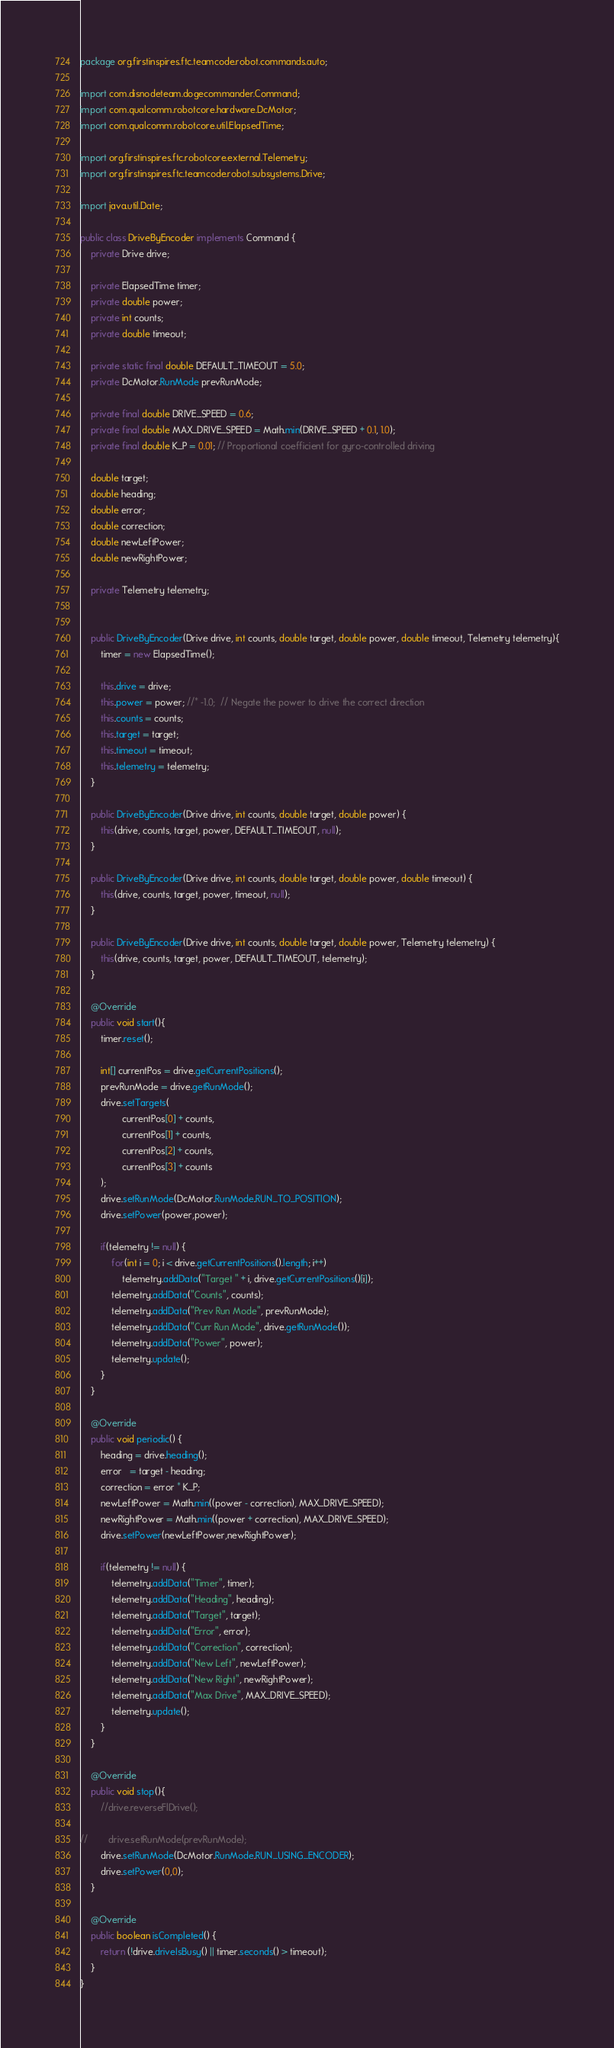Convert code to text. <code><loc_0><loc_0><loc_500><loc_500><_Java_>package org.firstinspires.ftc.teamcode.robot.commands.auto;

import com.disnodeteam.dogecommander.Command;
import com.qualcomm.robotcore.hardware.DcMotor;
import com.qualcomm.robotcore.util.ElapsedTime;

import org.firstinspires.ftc.robotcore.external.Telemetry;
import org.firstinspires.ftc.teamcode.robot.subsystems.Drive;

import java.util.Date;

public class DriveByEncoder implements Command {
    private Drive drive;

    private ElapsedTime timer;
    private double power;
    private int counts;
    private double timeout;

    private static final double DEFAULT_TIMEOUT = 5.0;
    private DcMotor.RunMode prevRunMode;

    private final double DRIVE_SPEED = 0.6;
    private final double MAX_DRIVE_SPEED = Math.min(DRIVE_SPEED + 0.1, 1.0);
    private final double K_P = 0.01; // Proportional coefficient for gyro-controlled driving

    double target;
    double heading;
    double error;
    double correction;
    double newLeftPower;
    double newRightPower;

    private Telemetry telemetry;


    public DriveByEncoder(Drive drive, int counts, double target, double power, double timeout, Telemetry telemetry){
        timer = new ElapsedTime();

        this.drive = drive;
        this.power = power; //* -1.0;  // Negate the power to drive the correct direction
        this.counts = counts;
        this.target = target;
        this.timeout = timeout;
        this.telemetry = telemetry;
    }

    public DriveByEncoder(Drive drive, int counts, double target, double power) {
        this(drive, counts, target, power, DEFAULT_TIMEOUT, null);
    }

    public DriveByEncoder(Drive drive, int counts, double target, double power, double timeout) {
        this(drive, counts, target, power, timeout, null);
    }

    public DriveByEncoder(Drive drive, int counts, double target, double power, Telemetry telemetry) {
        this(drive, counts, target, power, DEFAULT_TIMEOUT, telemetry);
    }

    @Override
    public void start(){
        timer.reset();

        int[] currentPos = drive.getCurrentPositions();
        prevRunMode = drive.getRunMode();
        drive.setTargets(
                currentPos[0] + counts,
                currentPos[1] + counts,
                currentPos[2] + counts,
                currentPos[3] + counts
        );
        drive.setRunMode(DcMotor.RunMode.RUN_TO_POSITION);
        drive.setPower(power,power);

        if(telemetry != null) {
            for(int i = 0; i < drive.getCurrentPositions().length; i++)
                telemetry.addData("Target " + i, drive.getCurrentPositions()[i]);
            telemetry.addData("Counts", counts);
            telemetry.addData("Prev Run Mode", prevRunMode);
            telemetry.addData("Curr Run Mode", drive.getRunMode());
            telemetry.addData("Power", power);
            telemetry.update();
        }
    }

    @Override
    public void periodic() {
        heading = drive.heading();
        error   = target - heading;
        correction = error * K_P;
        newLeftPower = Math.min((power - correction), MAX_DRIVE_SPEED);
        newRightPower = Math.min((power + correction), MAX_DRIVE_SPEED);
        drive.setPower(newLeftPower,newRightPower);

        if(telemetry != null) {
            telemetry.addData("Timer", timer);
            telemetry.addData("Heading", heading);
            telemetry.addData("Target", target);
            telemetry.addData("Error", error);
            telemetry.addData("Correction", correction);
            telemetry.addData("New Left", newLeftPower);
            telemetry.addData("New Right", newRightPower);
            telemetry.addData("Max Drive", MAX_DRIVE_SPEED);
            telemetry.update();
        }
    }

    @Override
    public void stop(){
        //drive.reverseFlDrive();

//        drive.setRunMode(prevRunMode);
        drive.setRunMode(DcMotor.RunMode.RUN_USING_ENCODER);
        drive.setPower(0,0);
    }

    @Override
    public boolean isCompleted() {
        return (!drive.driveIsBusy() || timer.seconds() > timeout);
    }
}


</code> 